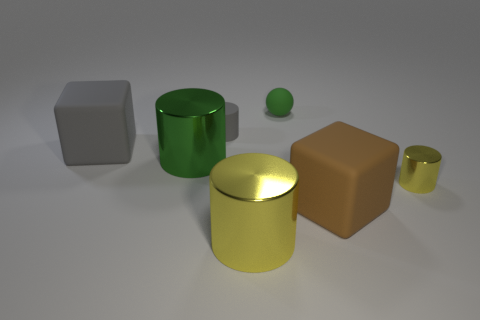Is the color of the tiny shiny cylinder the same as the object in front of the big brown object?
Keep it short and to the point. Yes. There is a yellow object that is the same material as the small yellow cylinder; what is its size?
Keep it short and to the point. Large. There is a rubber object that is the same color as the matte cylinder; what is its size?
Make the answer very short. Large. Are there any rubber things that are to the left of the block that is behind the tiny cylinder that is in front of the gray block?
Keep it short and to the point. No. What number of blocks are the same size as the green shiny cylinder?
Your answer should be compact. 2. Do the yellow metallic thing in front of the tiny yellow metallic cylinder and the sphere that is right of the big yellow object have the same size?
Provide a succinct answer. No. There is a metallic thing that is both behind the large yellow thing and on the left side of the small yellow thing; what is its shape?
Ensure brevity in your answer.  Cylinder. Is there a cylinder of the same color as the small sphere?
Provide a short and direct response. Yes. Is there a large gray object?
Ensure brevity in your answer.  Yes. What color is the rubber block that is in front of the green shiny object?
Offer a very short reply. Brown. 